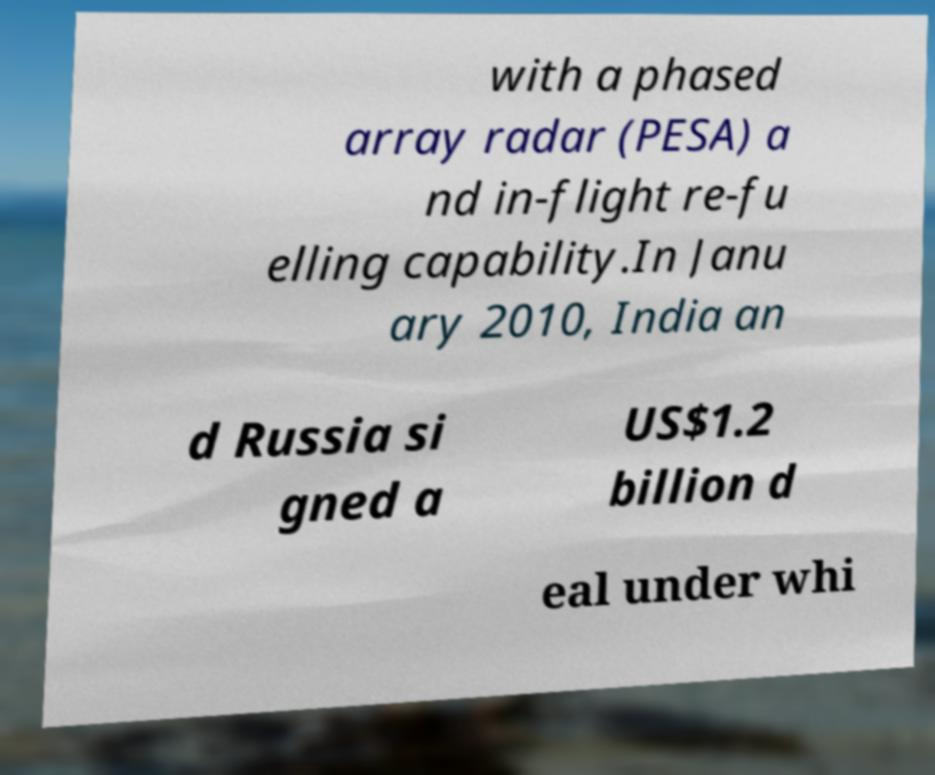Could you assist in decoding the text presented in this image and type it out clearly? with a phased array radar (PESA) a nd in-flight re-fu elling capability.In Janu ary 2010, India an d Russia si gned a US$1.2 billion d eal under whi 